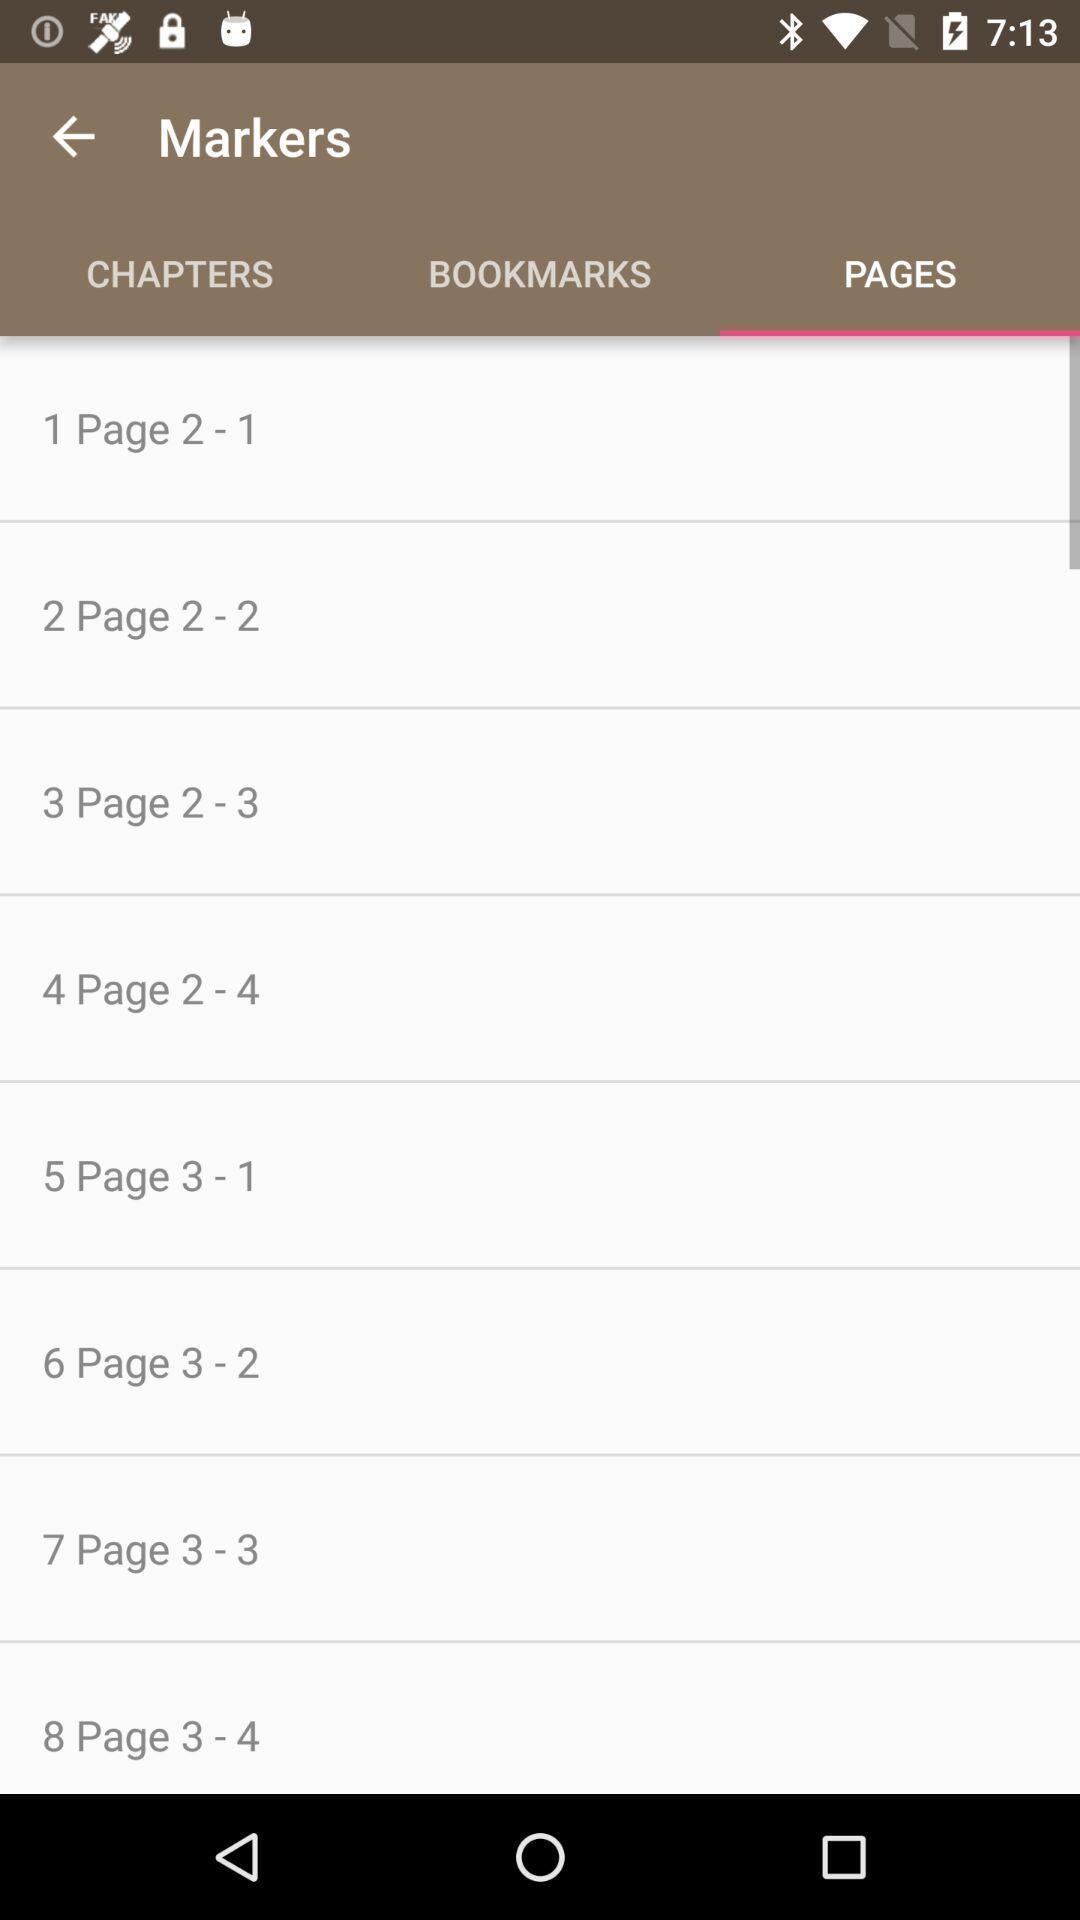Please provide a description for this image. Screen displaying the list of multiple pages. 